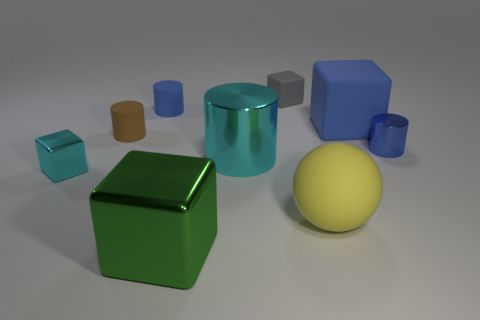There is a tiny cube that is the same color as the big metal cylinder; what material is it?
Your answer should be compact. Metal. There is another large rubber object that is the same shape as the large green thing; what color is it?
Offer a terse response. Blue. There is a block that is to the right of the small cyan metal object and in front of the large cyan cylinder; what is its size?
Give a very brief answer. Large. Is the shape of the small blue object on the right side of the large shiny cube the same as the large rubber object to the left of the large blue object?
Your response must be concise. No. There is a tiny object that is the same color as the large cylinder; what shape is it?
Your answer should be compact. Cube. How many yellow spheres have the same material as the tiny brown thing?
Make the answer very short. 1. What is the shape of the small thing that is to the right of the large cyan metallic thing and behind the blue shiny object?
Your answer should be compact. Cube. Does the small cylinder on the left side of the blue matte cylinder have the same material as the big cylinder?
Give a very brief answer. No. Is there anything else that is the same material as the large green object?
Your answer should be very brief. Yes. The shiny block that is the same size as the gray thing is what color?
Offer a very short reply. Cyan. 